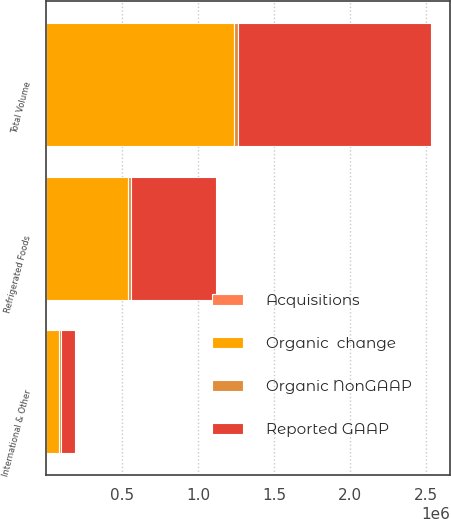Convert chart to OTSL. <chart><loc_0><loc_0><loc_500><loc_500><stacked_bar_chart><ecel><fcel>Refrigerated Foods<fcel>International & Other<fcel>Total Volume<nl><fcel>Reported GAAP<fcel>558843<fcel>95600<fcel>1.26529e+06<nl><fcel>Organic NonGAAP<fcel>22757<fcel>9807<fcel>32564<nl><fcel>Organic  change<fcel>536086<fcel>85793<fcel>1.23273e+06<nl><fcel>Acquisitions<fcel>2<fcel>6.1<fcel>3.3<nl></chart> 